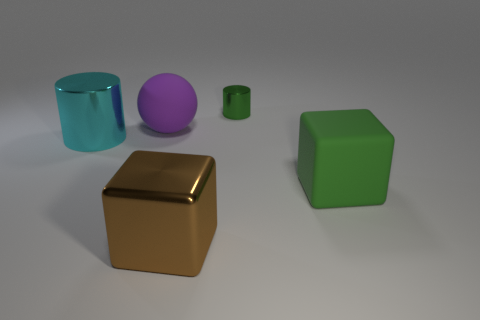Add 4 small yellow rubber things. How many objects exist? 9 Subtract 0 brown spheres. How many objects are left? 5 Subtract all blocks. How many objects are left? 3 Subtract all green balls. Subtract all blue cylinders. How many balls are left? 1 Subtract all green cylinders. How many green cubes are left? 1 Subtract all large balls. Subtract all big spheres. How many objects are left? 3 Add 2 tiny green metallic things. How many tiny green metallic things are left? 3 Add 4 purple matte balls. How many purple matte balls exist? 5 